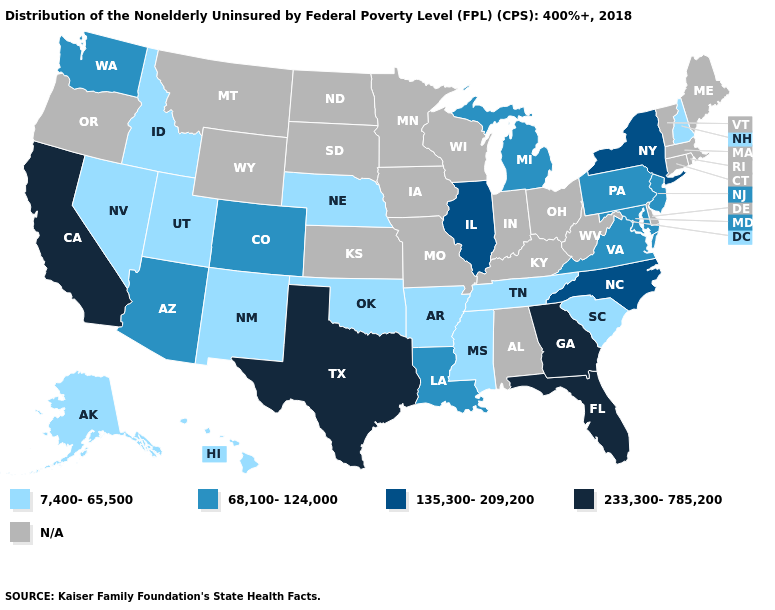What is the lowest value in the USA?
Answer briefly. 7,400-65,500. Name the states that have a value in the range 233,300-785,200?
Answer briefly. California, Florida, Georgia, Texas. Among the states that border California , does Arizona have the lowest value?
Quick response, please. No. Name the states that have a value in the range N/A?
Keep it brief. Alabama, Connecticut, Delaware, Indiana, Iowa, Kansas, Kentucky, Maine, Massachusetts, Minnesota, Missouri, Montana, North Dakota, Ohio, Oregon, Rhode Island, South Dakota, Vermont, West Virginia, Wisconsin, Wyoming. Does Mississippi have the lowest value in the USA?
Be succinct. Yes. Does Louisiana have the lowest value in the South?
Quick response, please. No. What is the value of Wyoming?
Keep it brief. N/A. What is the value of Idaho?
Answer briefly. 7,400-65,500. Does Georgia have the highest value in the USA?
Short answer required. Yes. What is the value of Nebraska?
Answer briefly. 7,400-65,500. What is the lowest value in states that border Mississippi?
Keep it brief. 7,400-65,500. Is the legend a continuous bar?
Answer briefly. No. Name the states that have a value in the range 233,300-785,200?
Quick response, please. California, Florida, Georgia, Texas. Is the legend a continuous bar?
Concise answer only. No. Which states have the highest value in the USA?
Be succinct. California, Florida, Georgia, Texas. 